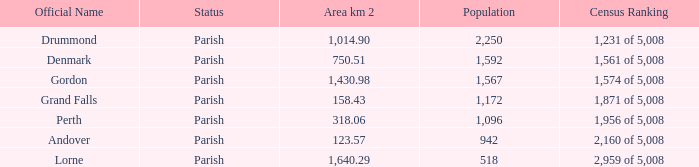51? Denmark. 